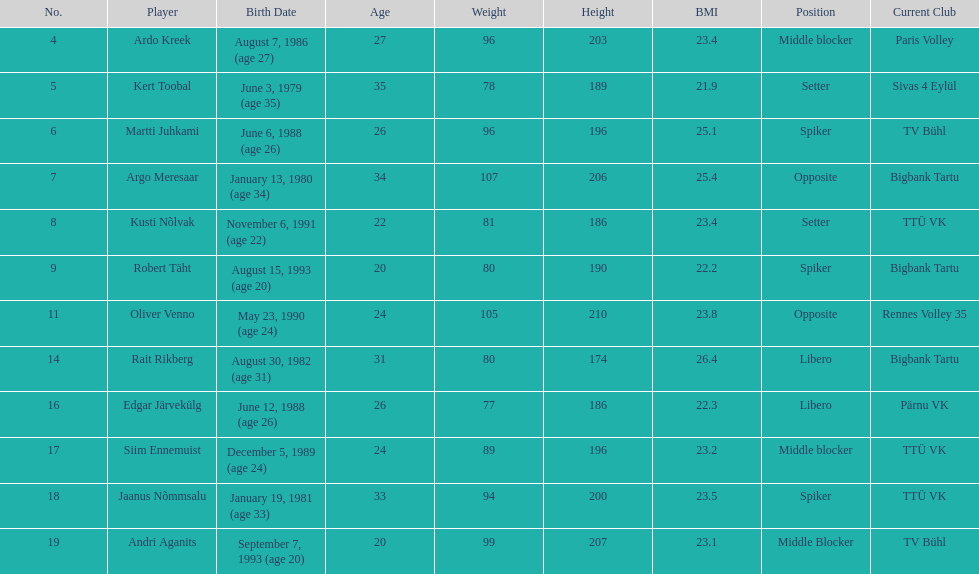What is the height difference between oliver venno and rait rikberg? 36. Parse the table in full. {'header': ['No.', 'Player', 'Birth Date', 'Age', 'Weight', 'Height', 'BMI', 'Position', 'Current Club'], 'rows': [['4', 'Ardo Kreek', 'August 7, 1986 (age\xa027)', '27', '96', '203', '23.4', 'Middle blocker', 'Paris Volley'], ['5', 'Kert Toobal', 'June 3, 1979 (age\xa035)', '35', '78', '189', '21.9', 'Setter', 'Sivas 4 Eylül'], ['6', 'Martti Juhkami', 'June 6, 1988 (age\xa026)', '26', '96', '196', '25.1', 'Spiker', 'TV Bühl'], ['7', 'Argo Meresaar', 'January 13, 1980 (age\xa034)', '34', '107', '206', '25.4', 'Opposite', 'Bigbank Tartu'], ['8', 'Kusti Nõlvak', 'November 6, 1991 (age\xa022)', '22', '81', '186', '23.4', 'Setter', 'TTÜ VK'], ['9', 'Robert Täht', 'August 15, 1993 (age\xa020)', '20', '80', '190', '22.2', 'Spiker', 'Bigbank Tartu'], ['11', 'Oliver Venno', 'May 23, 1990 (age\xa024)', '24', '105', '210', '23.8', 'Opposite', 'Rennes Volley 35'], ['14', 'Rait Rikberg', 'August 30, 1982 (age\xa031)', '31', '80', '174', '26.4', 'Libero', 'Bigbank Tartu'], ['16', 'Edgar Järvekülg', 'June 12, 1988 (age\xa026)', '26', '77', '186', '22.3', 'Libero', 'Pärnu VK'], ['17', 'Siim Ennemuist', 'December 5, 1989 (age\xa024)', '24', '89', '196', '23.2', 'Middle blocker', 'TTÜ VK'], ['18', 'Jaanus Nõmmsalu', 'January 19, 1981 (age\xa033)', '33', '94', '200', '23.5', 'Spiker', 'TTÜ VK'], ['19', 'Andri Aganits', 'September 7, 1993 (age\xa020)', '20', '99', '207', '23.1', 'Middle Blocker', 'TV Bühl']]} 